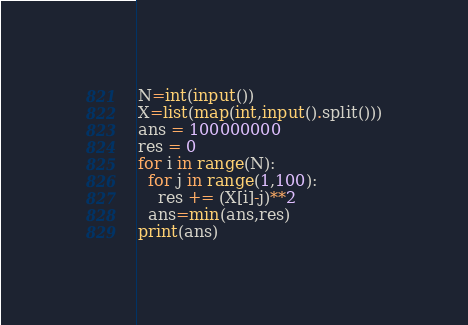Convert code to text. <code><loc_0><loc_0><loc_500><loc_500><_Python_>N=int(input())
X=list(map(int,input().split()))
ans = 100000000
res = 0
for i in range(N):
  for j in range(1,100):
    res += (X[i]-j)**2
  ans=min(ans,res)
print(ans)</code> 